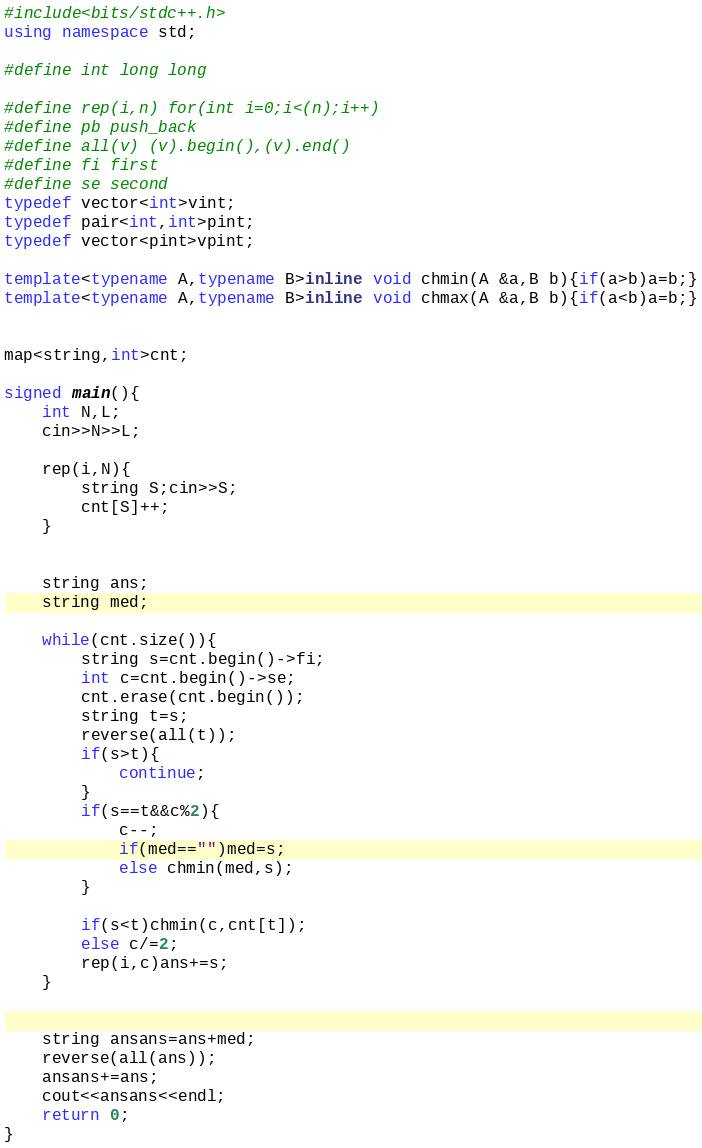<code> <loc_0><loc_0><loc_500><loc_500><_C++_>#include<bits/stdc++.h>
using namespace std;

#define int long long

#define rep(i,n) for(int i=0;i<(n);i++)
#define pb push_back
#define all(v) (v).begin(),(v).end()
#define fi first
#define se second
typedef vector<int>vint;
typedef pair<int,int>pint;
typedef vector<pint>vpint;

template<typename A,typename B>inline void chmin(A &a,B b){if(a>b)a=b;}
template<typename A,typename B>inline void chmax(A &a,B b){if(a<b)a=b;}


map<string,int>cnt;

signed main(){
    int N,L;
    cin>>N>>L;

    rep(i,N){
        string S;cin>>S;
        cnt[S]++;
    }


    string ans;
    string med;

    while(cnt.size()){
        string s=cnt.begin()->fi;
        int c=cnt.begin()->se;
        cnt.erase(cnt.begin());
        string t=s;
        reverse(all(t));
        if(s>t){
            continue;
        }
        if(s==t&&c%2){
            c--;
            if(med=="")med=s;
            else chmin(med,s);
        }

        if(s<t)chmin(c,cnt[t]);
        else c/=2;
        rep(i,c)ans+=s;
    }


    string ansans=ans+med;
    reverse(all(ans));
    ansans+=ans;
    cout<<ansans<<endl;
    return 0;
}</code> 